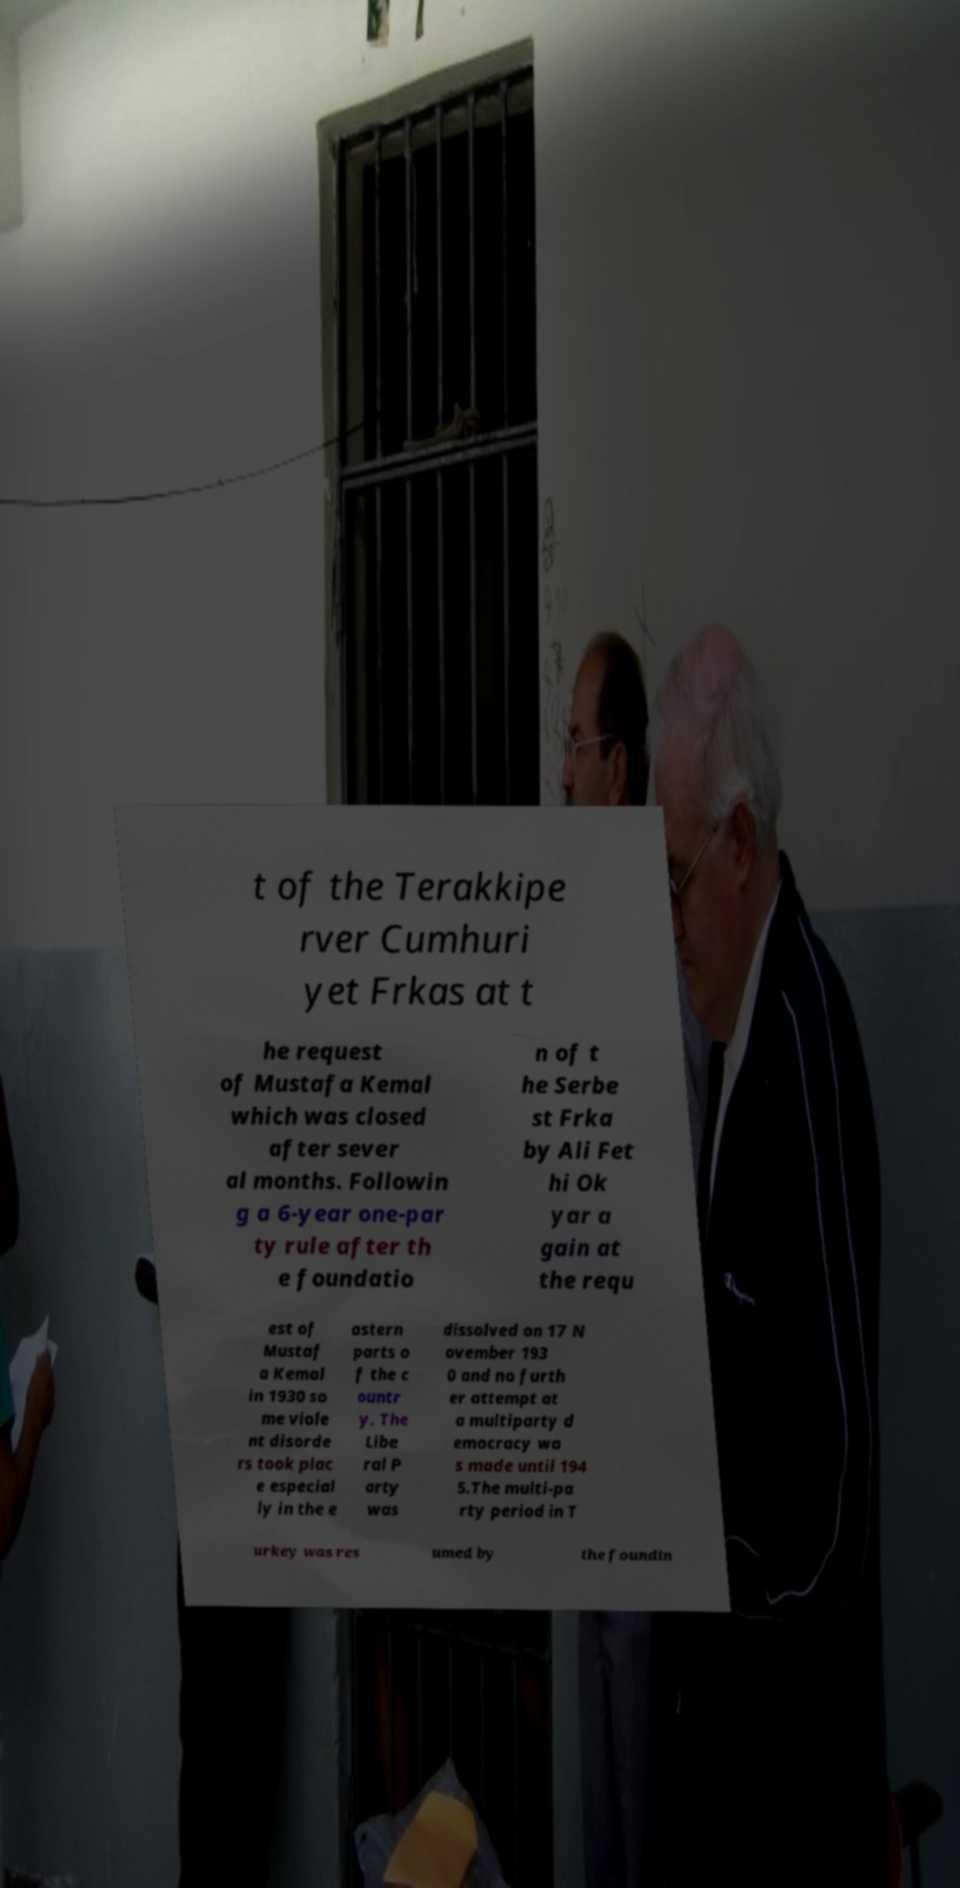Could you extract and type out the text from this image? t of the Terakkipe rver Cumhuri yet Frkas at t he request of Mustafa Kemal which was closed after sever al months. Followin g a 6-year one-par ty rule after th e foundatio n of t he Serbe st Frka by Ali Fet hi Ok yar a gain at the requ est of Mustaf a Kemal in 1930 so me viole nt disorde rs took plac e especial ly in the e astern parts o f the c ountr y. The Libe ral P arty was dissolved on 17 N ovember 193 0 and no furth er attempt at a multiparty d emocracy wa s made until 194 5.The multi-pa rty period in T urkey was res umed by the foundin 